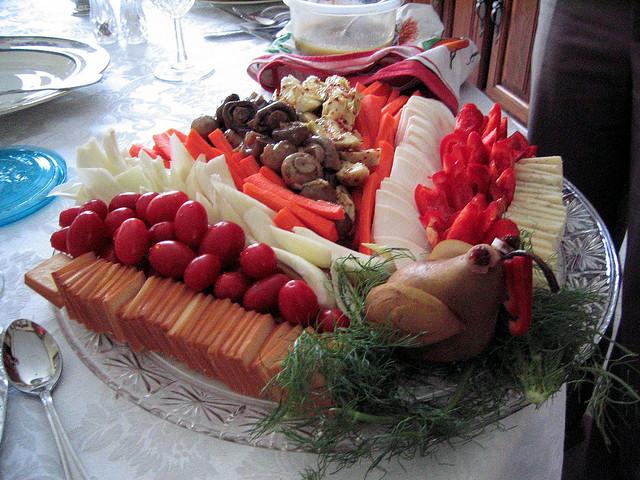Is there cheese on the plate?
Short answer required. Yes. What is the green stuff on the plate?
Write a very short answer. Fennel. Is there cheese?
Give a very brief answer. Yes. 